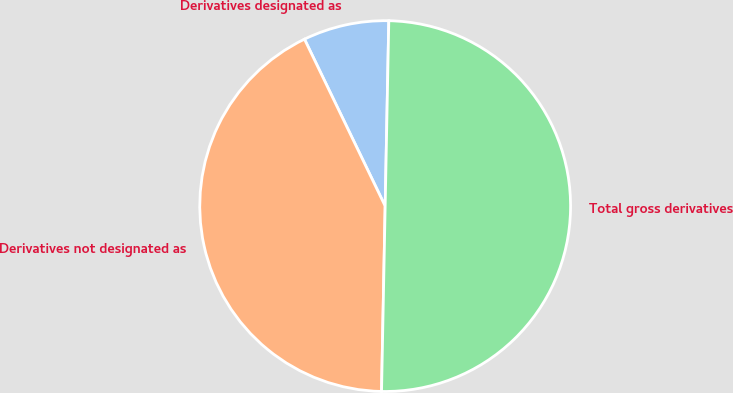Convert chart to OTSL. <chart><loc_0><loc_0><loc_500><loc_500><pie_chart><fcel>Derivatives designated as<fcel>Derivatives not designated as<fcel>Total gross derivatives<nl><fcel>7.48%<fcel>42.52%<fcel>50.0%<nl></chart> 